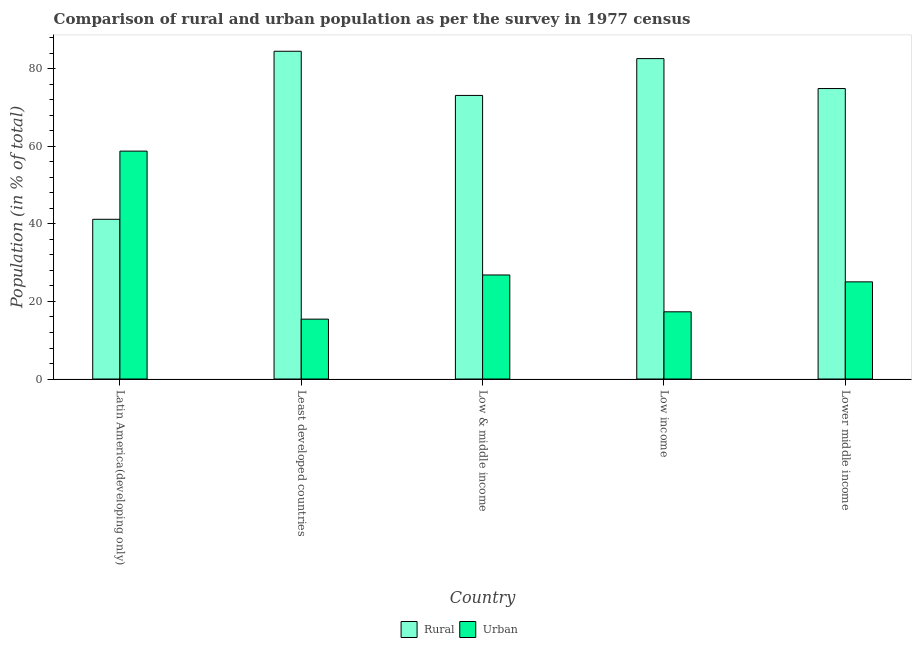How many groups of bars are there?
Your answer should be compact. 5. How many bars are there on the 2nd tick from the left?
Offer a terse response. 2. What is the label of the 1st group of bars from the left?
Provide a short and direct response. Latin America(developing only). What is the urban population in Lower middle income?
Your answer should be very brief. 25.06. Across all countries, what is the maximum rural population?
Keep it short and to the point. 84.55. Across all countries, what is the minimum urban population?
Provide a succinct answer. 15.45. In which country was the rural population maximum?
Your answer should be very brief. Least developed countries. In which country was the rural population minimum?
Your response must be concise. Latin America(developing only). What is the total urban population in the graph?
Your answer should be compact. 143.48. What is the difference between the urban population in Least developed countries and that in Low & middle income?
Keep it short and to the point. -11.39. What is the difference between the rural population in Low income and the urban population in Low & middle income?
Ensure brevity in your answer.  55.82. What is the average urban population per country?
Offer a very short reply. 28.7. What is the difference between the urban population and rural population in Low income?
Offer a very short reply. -65.32. In how many countries, is the rural population greater than 4 %?
Provide a short and direct response. 5. What is the ratio of the rural population in Latin America(developing only) to that in Lower middle income?
Your answer should be very brief. 0.55. What is the difference between the highest and the second highest urban population?
Your answer should be compact. 31.95. What is the difference between the highest and the lowest rural population?
Provide a short and direct response. 43.35. In how many countries, is the urban population greater than the average urban population taken over all countries?
Provide a succinct answer. 1. Is the sum of the rural population in Latin America(developing only) and Low income greater than the maximum urban population across all countries?
Your response must be concise. Yes. What does the 2nd bar from the left in Latin America(developing only) represents?
Offer a very short reply. Urban. What does the 2nd bar from the right in Latin America(developing only) represents?
Give a very brief answer. Rural. How many bars are there?
Your answer should be very brief. 10. How many countries are there in the graph?
Your response must be concise. 5. Does the graph contain any zero values?
Provide a short and direct response. No. Does the graph contain grids?
Your answer should be very brief. No. How many legend labels are there?
Offer a very short reply. 2. What is the title of the graph?
Keep it short and to the point. Comparison of rural and urban population as per the survey in 1977 census. Does "Public funds" appear as one of the legend labels in the graph?
Your response must be concise. No. What is the label or title of the X-axis?
Offer a terse response. Country. What is the label or title of the Y-axis?
Make the answer very short. Population (in % of total). What is the Population (in % of total) in Rural in Latin America(developing only)?
Provide a short and direct response. 41.21. What is the Population (in % of total) of Urban in Latin America(developing only)?
Offer a terse response. 58.79. What is the Population (in % of total) of Rural in Least developed countries?
Your response must be concise. 84.55. What is the Population (in % of total) in Urban in Least developed countries?
Your response must be concise. 15.45. What is the Population (in % of total) of Rural in Low & middle income?
Provide a succinct answer. 73.16. What is the Population (in % of total) of Urban in Low & middle income?
Make the answer very short. 26.84. What is the Population (in % of total) of Rural in Low income?
Offer a very short reply. 82.66. What is the Population (in % of total) in Urban in Low income?
Provide a short and direct response. 17.34. What is the Population (in % of total) in Rural in Lower middle income?
Give a very brief answer. 74.94. What is the Population (in % of total) of Urban in Lower middle income?
Make the answer very short. 25.06. Across all countries, what is the maximum Population (in % of total) of Rural?
Offer a terse response. 84.55. Across all countries, what is the maximum Population (in % of total) in Urban?
Provide a short and direct response. 58.79. Across all countries, what is the minimum Population (in % of total) of Rural?
Ensure brevity in your answer.  41.21. Across all countries, what is the minimum Population (in % of total) in Urban?
Ensure brevity in your answer.  15.45. What is the total Population (in % of total) in Rural in the graph?
Give a very brief answer. 356.52. What is the total Population (in % of total) of Urban in the graph?
Provide a short and direct response. 143.48. What is the difference between the Population (in % of total) in Rural in Latin America(developing only) and that in Least developed countries?
Ensure brevity in your answer.  -43.35. What is the difference between the Population (in % of total) of Urban in Latin America(developing only) and that in Least developed countries?
Keep it short and to the point. 43.35. What is the difference between the Population (in % of total) of Rural in Latin America(developing only) and that in Low & middle income?
Your answer should be very brief. -31.95. What is the difference between the Population (in % of total) of Urban in Latin America(developing only) and that in Low & middle income?
Ensure brevity in your answer.  31.95. What is the difference between the Population (in % of total) in Rural in Latin America(developing only) and that in Low income?
Your answer should be compact. -41.45. What is the difference between the Population (in % of total) in Urban in Latin America(developing only) and that in Low income?
Keep it short and to the point. 41.45. What is the difference between the Population (in % of total) of Rural in Latin America(developing only) and that in Lower middle income?
Ensure brevity in your answer.  -33.73. What is the difference between the Population (in % of total) in Urban in Latin America(developing only) and that in Lower middle income?
Your answer should be compact. 33.73. What is the difference between the Population (in % of total) in Rural in Least developed countries and that in Low & middle income?
Your answer should be compact. 11.39. What is the difference between the Population (in % of total) of Urban in Least developed countries and that in Low & middle income?
Provide a succinct answer. -11.39. What is the difference between the Population (in % of total) in Rural in Least developed countries and that in Low income?
Offer a terse response. 1.89. What is the difference between the Population (in % of total) in Urban in Least developed countries and that in Low income?
Make the answer very short. -1.89. What is the difference between the Population (in % of total) of Rural in Least developed countries and that in Lower middle income?
Keep it short and to the point. 9.62. What is the difference between the Population (in % of total) of Urban in Least developed countries and that in Lower middle income?
Make the answer very short. -9.62. What is the difference between the Population (in % of total) in Rural in Low & middle income and that in Low income?
Provide a short and direct response. -9.5. What is the difference between the Population (in % of total) of Urban in Low & middle income and that in Low income?
Keep it short and to the point. 9.5. What is the difference between the Population (in % of total) of Rural in Low & middle income and that in Lower middle income?
Make the answer very short. -1.77. What is the difference between the Population (in % of total) in Urban in Low & middle income and that in Lower middle income?
Offer a terse response. 1.77. What is the difference between the Population (in % of total) of Rural in Low income and that in Lower middle income?
Provide a short and direct response. 7.73. What is the difference between the Population (in % of total) of Urban in Low income and that in Lower middle income?
Give a very brief answer. -7.73. What is the difference between the Population (in % of total) of Rural in Latin America(developing only) and the Population (in % of total) of Urban in Least developed countries?
Give a very brief answer. 25.76. What is the difference between the Population (in % of total) in Rural in Latin America(developing only) and the Population (in % of total) in Urban in Low & middle income?
Provide a succinct answer. 14.37. What is the difference between the Population (in % of total) of Rural in Latin America(developing only) and the Population (in % of total) of Urban in Low income?
Provide a short and direct response. 23.87. What is the difference between the Population (in % of total) in Rural in Latin America(developing only) and the Population (in % of total) in Urban in Lower middle income?
Ensure brevity in your answer.  16.14. What is the difference between the Population (in % of total) of Rural in Least developed countries and the Population (in % of total) of Urban in Low & middle income?
Your answer should be very brief. 57.71. What is the difference between the Population (in % of total) of Rural in Least developed countries and the Population (in % of total) of Urban in Low income?
Provide a short and direct response. 67.21. What is the difference between the Population (in % of total) of Rural in Least developed countries and the Population (in % of total) of Urban in Lower middle income?
Give a very brief answer. 59.49. What is the difference between the Population (in % of total) of Rural in Low & middle income and the Population (in % of total) of Urban in Low income?
Offer a very short reply. 55.82. What is the difference between the Population (in % of total) in Rural in Low & middle income and the Population (in % of total) in Urban in Lower middle income?
Provide a short and direct response. 48.1. What is the difference between the Population (in % of total) in Rural in Low income and the Population (in % of total) in Urban in Lower middle income?
Your answer should be compact. 57.6. What is the average Population (in % of total) of Rural per country?
Make the answer very short. 71.3. What is the average Population (in % of total) of Urban per country?
Keep it short and to the point. 28.7. What is the difference between the Population (in % of total) of Rural and Population (in % of total) of Urban in Latin America(developing only)?
Offer a terse response. -17.59. What is the difference between the Population (in % of total) of Rural and Population (in % of total) of Urban in Least developed countries?
Your response must be concise. 69.11. What is the difference between the Population (in % of total) of Rural and Population (in % of total) of Urban in Low & middle income?
Your answer should be very brief. 46.32. What is the difference between the Population (in % of total) in Rural and Population (in % of total) in Urban in Low income?
Provide a succinct answer. 65.32. What is the difference between the Population (in % of total) of Rural and Population (in % of total) of Urban in Lower middle income?
Your answer should be very brief. 49.87. What is the ratio of the Population (in % of total) of Rural in Latin America(developing only) to that in Least developed countries?
Offer a terse response. 0.49. What is the ratio of the Population (in % of total) in Urban in Latin America(developing only) to that in Least developed countries?
Give a very brief answer. 3.81. What is the ratio of the Population (in % of total) in Rural in Latin America(developing only) to that in Low & middle income?
Ensure brevity in your answer.  0.56. What is the ratio of the Population (in % of total) in Urban in Latin America(developing only) to that in Low & middle income?
Your answer should be compact. 2.19. What is the ratio of the Population (in % of total) in Rural in Latin America(developing only) to that in Low income?
Provide a succinct answer. 0.5. What is the ratio of the Population (in % of total) of Urban in Latin America(developing only) to that in Low income?
Your response must be concise. 3.39. What is the ratio of the Population (in % of total) of Rural in Latin America(developing only) to that in Lower middle income?
Offer a terse response. 0.55. What is the ratio of the Population (in % of total) of Urban in Latin America(developing only) to that in Lower middle income?
Provide a short and direct response. 2.35. What is the ratio of the Population (in % of total) in Rural in Least developed countries to that in Low & middle income?
Give a very brief answer. 1.16. What is the ratio of the Population (in % of total) of Urban in Least developed countries to that in Low & middle income?
Provide a short and direct response. 0.58. What is the ratio of the Population (in % of total) of Rural in Least developed countries to that in Low income?
Provide a short and direct response. 1.02. What is the ratio of the Population (in % of total) of Urban in Least developed countries to that in Low income?
Give a very brief answer. 0.89. What is the ratio of the Population (in % of total) in Rural in Least developed countries to that in Lower middle income?
Your answer should be compact. 1.13. What is the ratio of the Population (in % of total) in Urban in Least developed countries to that in Lower middle income?
Keep it short and to the point. 0.62. What is the ratio of the Population (in % of total) of Rural in Low & middle income to that in Low income?
Keep it short and to the point. 0.89. What is the ratio of the Population (in % of total) in Urban in Low & middle income to that in Low income?
Keep it short and to the point. 1.55. What is the ratio of the Population (in % of total) of Rural in Low & middle income to that in Lower middle income?
Your response must be concise. 0.98. What is the ratio of the Population (in % of total) in Urban in Low & middle income to that in Lower middle income?
Keep it short and to the point. 1.07. What is the ratio of the Population (in % of total) in Rural in Low income to that in Lower middle income?
Make the answer very short. 1.1. What is the ratio of the Population (in % of total) of Urban in Low income to that in Lower middle income?
Offer a very short reply. 0.69. What is the difference between the highest and the second highest Population (in % of total) in Rural?
Give a very brief answer. 1.89. What is the difference between the highest and the second highest Population (in % of total) in Urban?
Offer a very short reply. 31.95. What is the difference between the highest and the lowest Population (in % of total) in Rural?
Provide a short and direct response. 43.35. What is the difference between the highest and the lowest Population (in % of total) of Urban?
Provide a short and direct response. 43.35. 